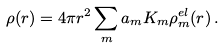Convert formula to latex. <formula><loc_0><loc_0><loc_500><loc_500>\rho ( r ) = 4 \pi r ^ { 2 } \sum _ { m } a _ { m } K _ { m } \rho _ { m } ^ { e l } ( r ) \, .</formula> 